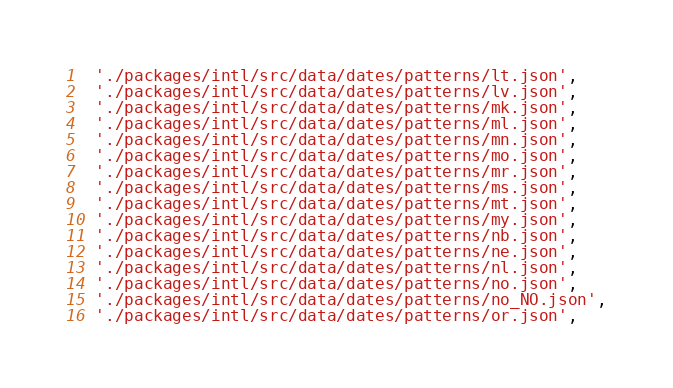Convert code to text. <code><loc_0><loc_0><loc_500><loc_500><_Dart_>  './packages/intl/src/data/dates/patterns/lt.json',
  './packages/intl/src/data/dates/patterns/lv.json',
  './packages/intl/src/data/dates/patterns/mk.json',
  './packages/intl/src/data/dates/patterns/ml.json',
  './packages/intl/src/data/dates/patterns/mn.json',
  './packages/intl/src/data/dates/patterns/mo.json',
  './packages/intl/src/data/dates/patterns/mr.json',
  './packages/intl/src/data/dates/patterns/ms.json',
  './packages/intl/src/data/dates/patterns/mt.json',
  './packages/intl/src/data/dates/patterns/my.json',
  './packages/intl/src/data/dates/patterns/nb.json',
  './packages/intl/src/data/dates/patterns/ne.json',
  './packages/intl/src/data/dates/patterns/nl.json',
  './packages/intl/src/data/dates/patterns/no.json',
  './packages/intl/src/data/dates/patterns/no_NO.json',
  './packages/intl/src/data/dates/patterns/or.json',</code> 